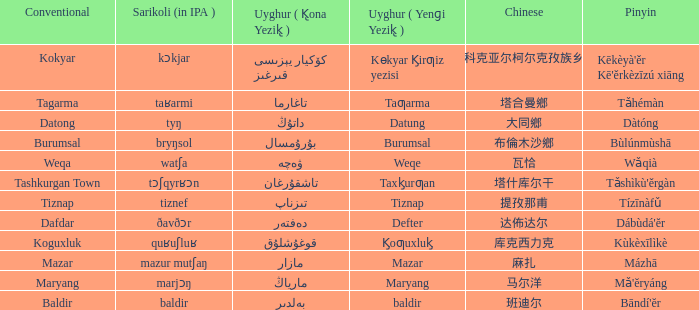Name the conventional for تاغارما Tagarma. 